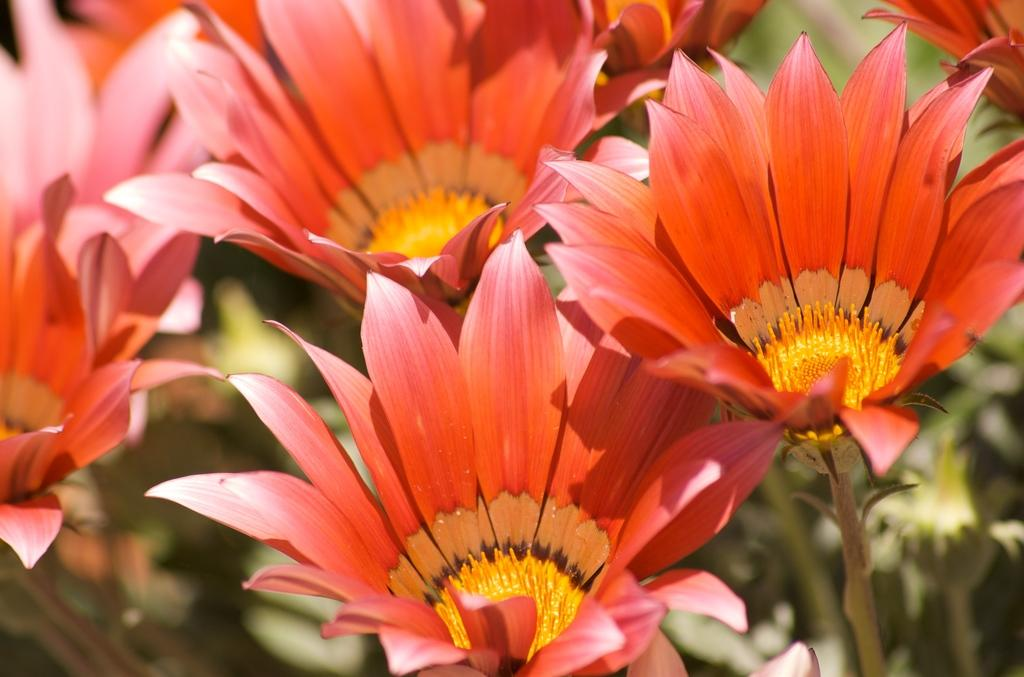What type of living organisms can be seen in the image? There are flowers in the image. Can you describe the background of the image? The background of the image is blurred. What kind of surprise can be seen coming from the window in the image? There is no window or surprise present in the image; it only features flowers with a blurred background. 